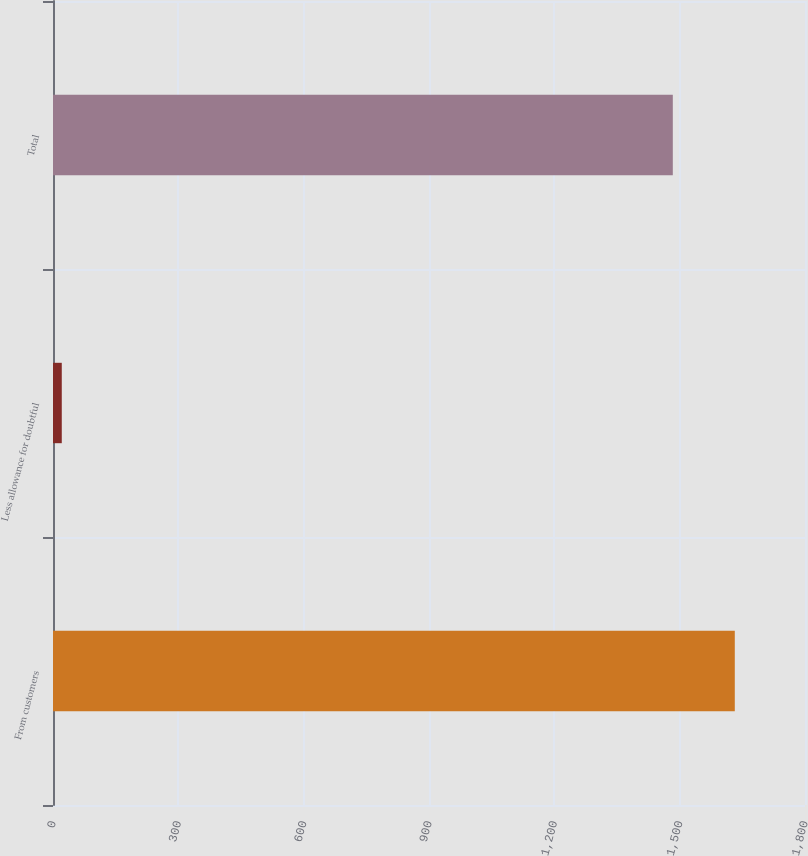Convert chart to OTSL. <chart><loc_0><loc_0><loc_500><loc_500><bar_chart><fcel>From customers<fcel>Less allowance for doubtful<fcel>Total<nl><fcel>1631.96<fcel>21<fcel>1483.6<nl></chart> 